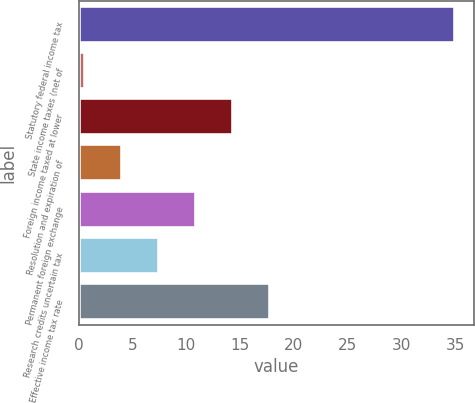<chart> <loc_0><loc_0><loc_500><loc_500><bar_chart><fcel>Statutory federal income tax<fcel>State income taxes (net of<fcel>Foreign income taxed at lower<fcel>Resolution and expiration of<fcel>Permanent foreign exchange<fcel>Research credits uncertain tax<fcel>Effective income tax rate<nl><fcel>35<fcel>0.6<fcel>14.36<fcel>4.04<fcel>10.92<fcel>7.48<fcel>17.8<nl></chart> 